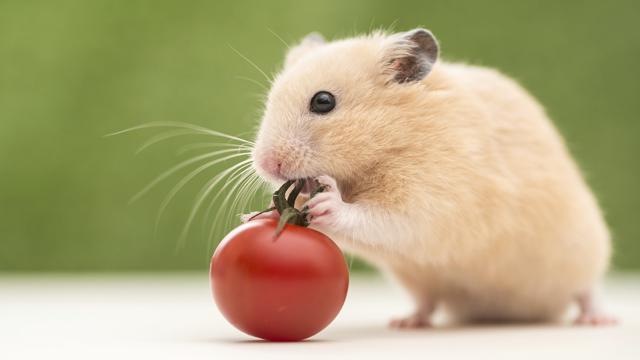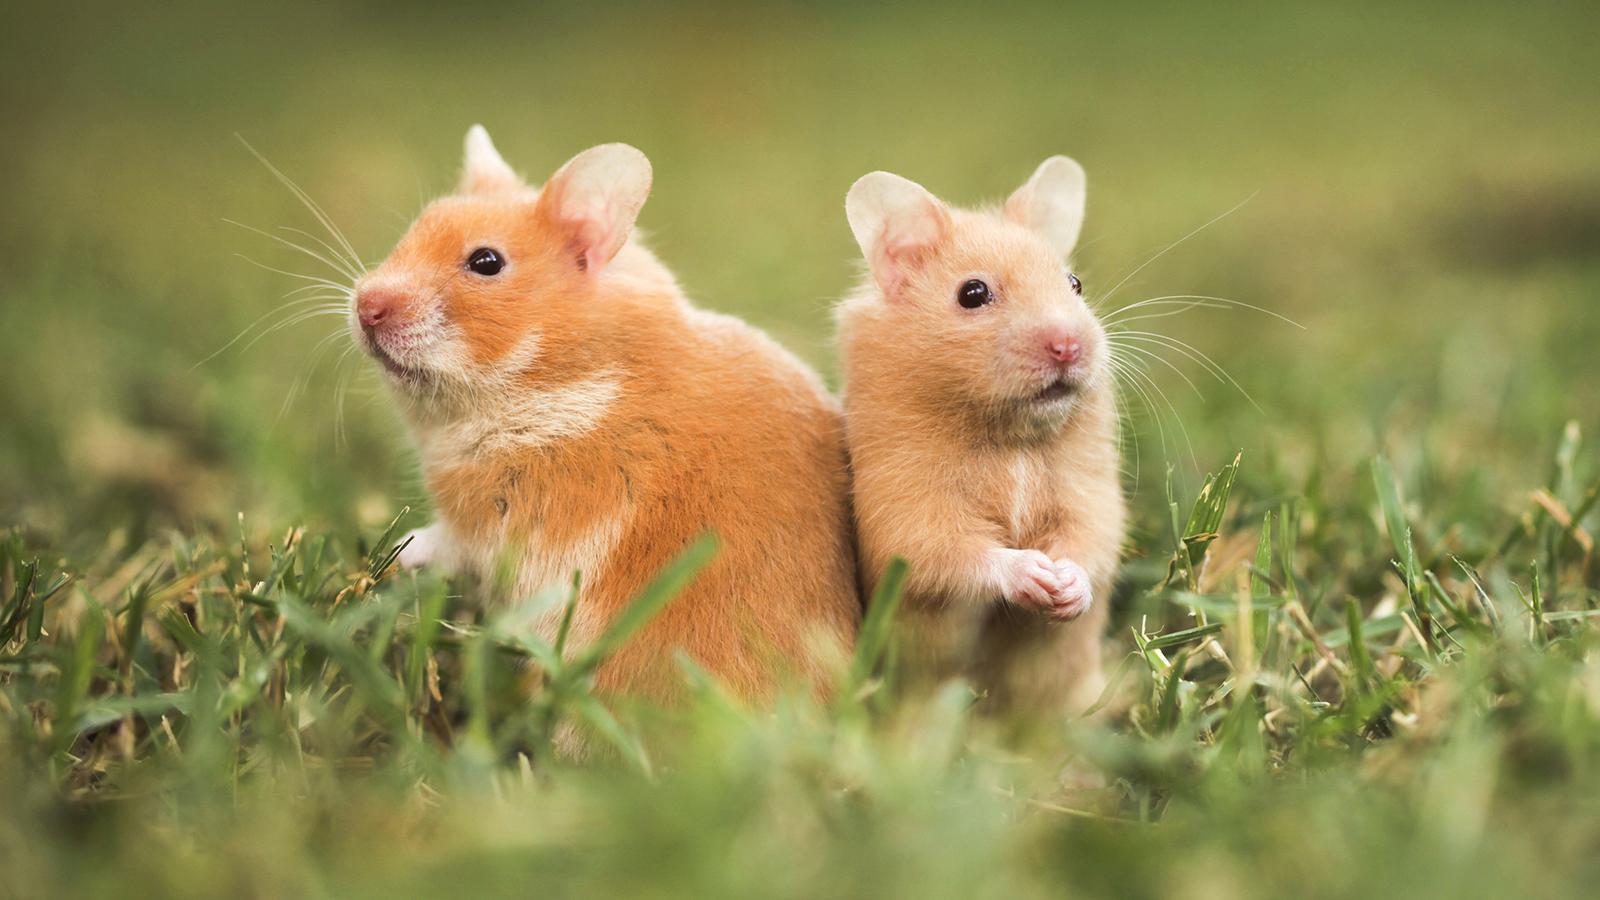The first image is the image on the left, the second image is the image on the right. Evaluate the accuracy of this statement regarding the images: "An image shows one hamster on the right of a round object with orange-red coloring.". Is it true? Answer yes or no. Yes. The first image is the image on the left, the second image is the image on the right. Evaluate the accuracy of this statement regarding the images: "The hamsters in each image appear sort of orangish, and the ones pictured by themselves also have some food they are eating.". Is it true? Answer yes or no. Yes. 